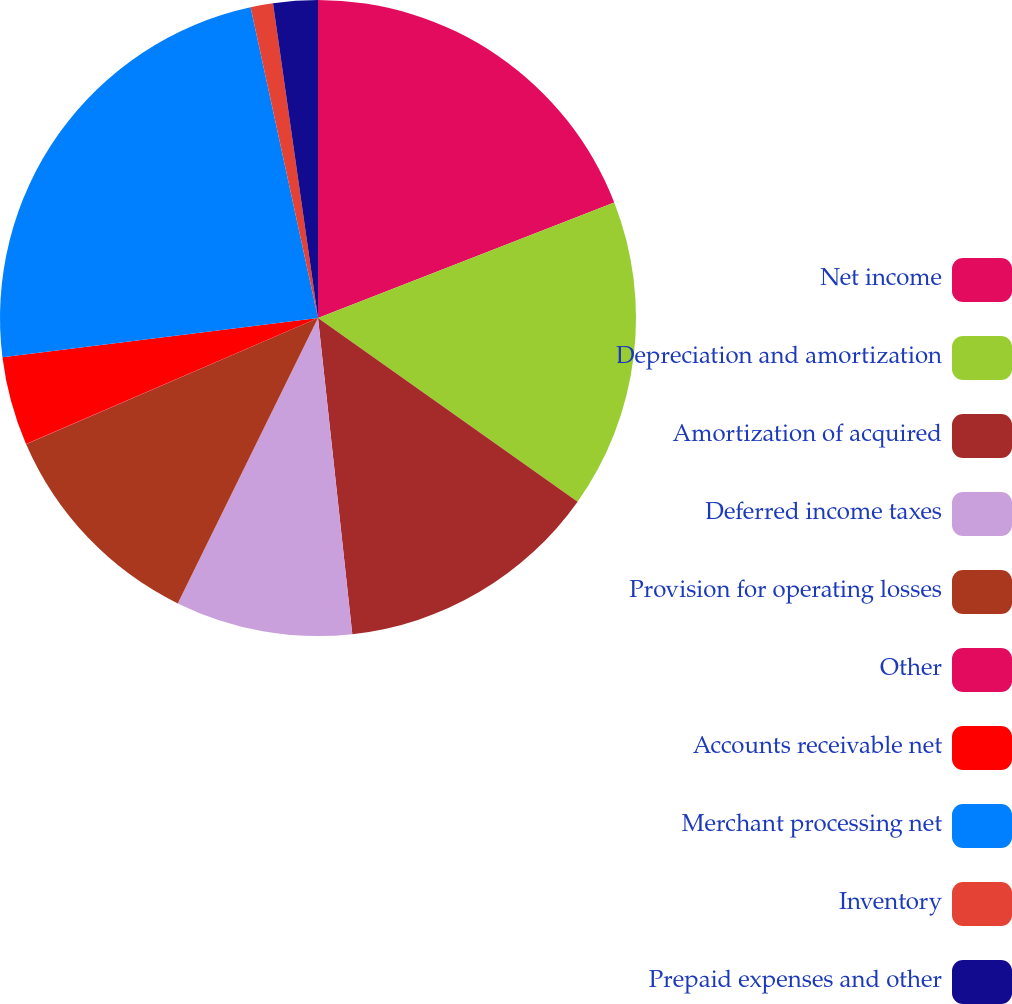<chart> <loc_0><loc_0><loc_500><loc_500><pie_chart><fcel>Net income<fcel>Depreciation and amortization<fcel>Amortization of acquired<fcel>Deferred income taxes<fcel>Provision for operating losses<fcel>Other<fcel>Accounts receivable net<fcel>Merchant processing net<fcel>Inventory<fcel>Prepaid expenses and other<nl><fcel>19.08%<fcel>15.72%<fcel>13.48%<fcel>8.99%<fcel>11.23%<fcel>0.02%<fcel>4.51%<fcel>23.57%<fcel>1.14%<fcel>2.26%<nl></chart> 